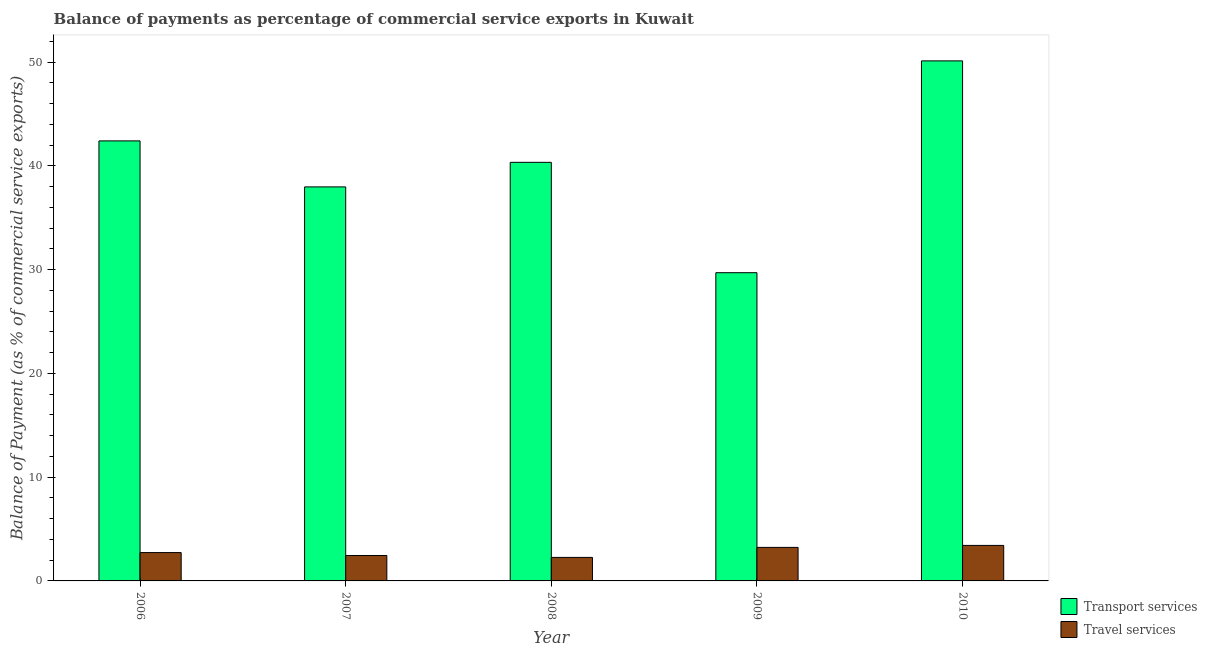How many different coloured bars are there?
Your answer should be compact. 2. Are the number of bars per tick equal to the number of legend labels?
Offer a terse response. Yes. Are the number of bars on each tick of the X-axis equal?
Your answer should be very brief. Yes. What is the label of the 2nd group of bars from the left?
Your answer should be compact. 2007. What is the balance of payments of transport services in 2009?
Offer a terse response. 29.71. Across all years, what is the maximum balance of payments of travel services?
Your response must be concise. 3.42. Across all years, what is the minimum balance of payments of travel services?
Your answer should be compact. 2.27. In which year was the balance of payments of transport services maximum?
Your answer should be compact. 2010. In which year was the balance of payments of transport services minimum?
Your answer should be very brief. 2009. What is the total balance of payments of transport services in the graph?
Give a very brief answer. 200.58. What is the difference between the balance of payments of transport services in 2006 and that in 2010?
Your answer should be very brief. -7.71. What is the difference between the balance of payments of travel services in 2010 and the balance of payments of transport services in 2007?
Ensure brevity in your answer.  0.97. What is the average balance of payments of transport services per year?
Your answer should be compact. 40.12. In how many years, is the balance of payments of transport services greater than 38 %?
Your response must be concise. 3. What is the ratio of the balance of payments of travel services in 2006 to that in 2007?
Offer a very short reply. 1.11. Is the difference between the balance of payments of travel services in 2006 and 2007 greater than the difference between the balance of payments of transport services in 2006 and 2007?
Your response must be concise. No. What is the difference between the highest and the second highest balance of payments of transport services?
Ensure brevity in your answer.  7.71. What is the difference between the highest and the lowest balance of payments of transport services?
Your response must be concise. 20.42. In how many years, is the balance of payments of transport services greater than the average balance of payments of transport services taken over all years?
Ensure brevity in your answer.  3. What does the 1st bar from the left in 2007 represents?
Give a very brief answer. Transport services. What does the 1st bar from the right in 2007 represents?
Give a very brief answer. Travel services. What is the difference between two consecutive major ticks on the Y-axis?
Offer a very short reply. 10. Are the values on the major ticks of Y-axis written in scientific E-notation?
Your answer should be very brief. No. Does the graph contain grids?
Give a very brief answer. No. How many legend labels are there?
Ensure brevity in your answer.  2. What is the title of the graph?
Make the answer very short. Balance of payments as percentage of commercial service exports in Kuwait. What is the label or title of the X-axis?
Offer a very short reply. Year. What is the label or title of the Y-axis?
Keep it short and to the point. Balance of Payment (as % of commercial service exports). What is the Balance of Payment (as % of commercial service exports) in Transport services in 2006?
Offer a very short reply. 42.41. What is the Balance of Payment (as % of commercial service exports) of Travel services in 2006?
Make the answer very short. 2.73. What is the Balance of Payment (as % of commercial service exports) in Transport services in 2007?
Give a very brief answer. 37.98. What is the Balance of Payment (as % of commercial service exports) of Travel services in 2007?
Your answer should be very brief. 2.45. What is the Balance of Payment (as % of commercial service exports) of Transport services in 2008?
Your answer should be very brief. 40.35. What is the Balance of Payment (as % of commercial service exports) of Travel services in 2008?
Your response must be concise. 2.27. What is the Balance of Payment (as % of commercial service exports) in Transport services in 2009?
Your answer should be very brief. 29.71. What is the Balance of Payment (as % of commercial service exports) in Travel services in 2009?
Keep it short and to the point. 3.23. What is the Balance of Payment (as % of commercial service exports) in Transport services in 2010?
Your answer should be compact. 50.13. What is the Balance of Payment (as % of commercial service exports) of Travel services in 2010?
Provide a succinct answer. 3.42. Across all years, what is the maximum Balance of Payment (as % of commercial service exports) of Transport services?
Keep it short and to the point. 50.13. Across all years, what is the maximum Balance of Payment (as % of commercial service exports) in Travel services?
Your answer should be very brief. 3.42. Across all years, what is the minimum Balance of Payment (as % of commercial service exports) in Transport services?
Your answer should be very brief. 29.71. Across all years, what is the minimum Balance of Payment (as % of commercial service exports) in Travel services?
Offer a terse response. 2.27. What is the total Balance of Payment (as % of commercial service exports) of Transport services in the graph?
Provide a succinct answer. 200.58. What is the total Balance of Payment (as % of commercial service exports) of Travel services in the graph?
Give a very brief answer. 14.1. What is the difference between the Balance of Payment (as % of commercial service exports) in Transport services in 2006 and that in 2007?
Give a very brief answer. 4.43. What is the difference between the Balance of Payment (as % of commercial service exports) of Travel services in 2006 and that in 2007?
Your answer should be very brief. 0.28. What is the difference between the Balance of Payment (as % of commercial service exports) of Transport services in 2006 and that in 2008?
Ensure brevity in your answer.  2.07. What is the difference between the Balance of Payment (as % of commercial service exports) of Travel services in 2006 and that in 2008?
Ensure brevity in your answer.  0.47. What is the difference between the Balance of Payment (as % of commercial service exports) of Transport services in 2006 and that in 2009?
Your answer should be compact. 12.7. What is the difference between the Balance of Payment (as % of commercial service exports) in Travel services in 2006 and that in 2009?
Provide a succinct answer. -0.5. What is the difference between the Balance of Payment (as % of commercial service exports) of Transport services in 2006 and that in 2010?
Provide a succinct answer. -7.71. What is the difference between the Balance of Payment (as % of commercial service exports) of Travel services in 2006 and that in 2010?
Your response must be concise. -0.69. What is the difference between the Balance of Payment (as % of commercial service exports) of Transport services in 2007 and that in 2008?
Keep it short and to the point. -2.37. What is the difference between the Balance of Payment (as % of commercial service exports) of Travel services in 2007 and that in 2008?
Ensure brevity in your answer.  0.18. What is the difference between the Balance of Payment (as % of commercial service exports) in Transport services in 2007 and that in 2009?
Your response must be concise. 8.27. What is the difference between the Balance of Payment (as % of commercial service exports) in Travel services in 2007 and that in 2009?
Offer a very short reply. -0.78. What is the difference between the Balance of Payment (as % of commercial service exports) in Transport services in 2007 and that in 2010?
Make the answer very short. -12.15. What is the difference between the Balance of Payment (as % of commercial service exports) of Travel services in 2007 and that in 2010?
Keep it short and to the point. -0.97. What is the difference between the Balance of Payment (as % of commercial service exports) of Transport services in 2008 and that in 2009?
Provide a short and direct response. 10.64. What is the difference between the Balance of Payment (as % of commercial service exports) of Travel services in 2008 and that in 2009?
Your answer should be very brief. -0.97. What is the difference between the Balance of Payment (as % of commercial service exports) of Transport services in 2008 and that in 2010?
Offer a very short reply. -9.78. What is the difference between the Balance of Payment (as % of commercial service exports) of Travel services in 2008 and that in 2010?
Make the answer very short. -1.16. What is the difference between the Balance of Payment (as % of commercial service exports) of Transport services in 2009 and that in 2010?
Your answer should be compact. -20.42. What is the difference between the Balance of Payment (as % of commercial service exports) in Travel services in 2009 and that in 2010?
Your answer should be very brief. -0.19. What is the difference between the Balance of Payment (as % of commercial service exports) in Transport services in 2006 and the Balance of Payment (as % of commercial service exports) in Travel services in 2007?
Your answer should be very brief. 39.96. What is the difference between the Balance of Payment (as % of commercial service exports) of Transport services in 2006 and the Balance of Payment (as % of commercial service exports) of Travel services in 2008?
Offer a terse response. 40.15. What is the difference between the Balance of Payment (as % of commercial service exports) of Transport services in 2006 and the Balance of Payment (as % of commercial service exports) of Travel services in 2009?
Provide a succinct answer. 39.18. What is the difference between the Balance of Payment (as % of commercial service exports) in Transport services in 2006 and the Balance of Payment (as % of commercial service exports) in Travel services in 2010?
Your answer should be very brief. 38.99. What is the difference between the Balance of Payment (as % of commercial service exports) of Transport services in 2007 and the Balance of Payment (as % of commercial service exports) of Travel services in 2008?
Ensure brevity in your answer.  35.72. What is the difference between the Balance of Payment (as % of commercial service exports) of Transport services in 2007 and the Balance of Payment (as % of commercial service exports) of Travel services in 2009?
Provide a succinct answer. 34.75. What is the difference between the Balance of Payment (as % of commercial service exports) in Transport services in 2007 and the Balance of Payment (as % of commercial service exports) in Travel services in 2010?
Keep it short and to the point. 34.56. What is the difference between the Balance of Payment (as % of commercial service exports) of Transport services in 2008 and the Balance of Payment (as % of commercial service exports) of Travel services in 2009?
Keep it short and to the point. 37.12. What is the difference between the Balance of Payment (as % of commercial service exports) of Transport services in 2008 and the Balance of Payment (as % of commercial service exports) of Travel services in 2010?
Keep it short and to the point. 36.92. What is the difference between the Balance of Payment (as % of commercial service exports) of Transport services in 2009 and the Balance of Payment (as % of commercial service exports) of Travel services in 2010?
Give a very brief answer. 26.29. What is the average Balance of Payment (as % of commercial service exports) in Transport services per year?
Give a very brief answer. 40.12. What is the average Balance of Payment (as % of commercial service exports) in Travel services per year?
Keep it short and to the point. 2.82. In the year 2006, what is the difference between the Balance of Payment (as % of commercial service exports) of Transport services and Balance of Payment (as % of commercial service exports) of Travel services?
Offer a very short reply. 39.68. In the year 2007, what is the difference between the Balance of Payment (as % of commercial service exports) in Transport services and Balance of Payment (as % of commercial service exports) in Travel services?
Make the answer very short. 35.53. In the year 2008, what is the difference between the Balance of Payment (as % of commercial service exports) in Transport services and Balance of Payment (as % of commercial service exports) in Travel services?
Offer a terse response. 38.08. In the year 2009, what is the difference between the Balance of Payment (as % of commercial service exports) of Transport services and Balance of Payment (as % of commercial service exports) of Travel services?
Your response must be concise. 26.48. In the year 2010, what is the difference between the Balance of Payment (as % of commercial service exports) in Transport services and Balance of Payment (as % of commercial service exports) in Travel services?
Make the answer very short. 46.7. What is the ratio of the Balance of Payment (as % of commercial service exports) in Transport services in 2006 to that in 2007?
Your answer should be compact. 1.12. What is the ratio of the Balance of Payment (as % of commercial service exports) of Travel services in 2006 to that in 2007?
Your answer should be very brief. 1.11. What is the ratio of the Balance of Payment (as % of commercial service exports) in Transport services in 2006 to that in 2008?
Your answer should be compact. 1.05. What is the ratio of the Balance of Payment (as % of commercial service exports) of Travel services in 2006 to that in 2008?
Your response must be concise. 1.21. What is the ratio of the Balance of Payment (as % of commercial service exports) in Transport services in 2006 to that in 2009?
Your response must be concise. 1.43. What is the ratio of the Balance of Payment (as % of commercial service exports) of Travel services in 2006 to that in 2009?
Provide a short and direct response. 0.85. What is the ratio of the Balance of Payment (as % of commercial service exports) of Transport services in 2006 to that in 2010?
Offer a very short reply. 0.85. What is the ratio of the Balance of Payment (as % of commercial service exports) in Travel services in 2006 to that in 2010?
Ensure brevity in your answer.  0.8. What is the ratio of the Balance of Payment (as % of commercial service exports) in Transport services in 2007 to that in 2008?
Make the answer very short. 0.94. What is the ratio of the Balance of Payment (as % of commercial service exports) of Travel services in 2007 to that in 2008?
Ensure brevity in your answer.  1.08. What is the ratio of the Balance of Payment (as % of commercial service exports) of Transport services in 2007 to that in 2009?
Make the answer very short. 1.28. What is the ratio of the Balance of Payment (as % of commercial service exports) of Travel services in 2007 to that in 2009?
Your response must be concise. 0.76. What is the ratio of the Balance of Payment (as % of commercial service exports) in Transport services in 2007 to that in 2010?
Give a very brief answer. 0.76. What is the ratio of the Balance of Payment (as % of commercial service exports) of Travel services in 2007 to that in 2010?
Your response must be concise. 0.72. What is the ratio of the Balance of Payment (as % of commercial service exports) in Transport services in 2008 to that in 2009?
Offer a very short reply. 1.36. What is the ratio of the Balance of Payment (as % of commercial service exports) in Travel services in 2008 to that in 2009?
Offer a very short reply. 0.7. What is the ratio of the Balance of Payment (as % of commercial service exports) of Transport services in 2008 to that in 2010?
Keep it short and to the point. 0.8. What is the ratio of the Balance of Payment (as % of commercial service exports) in Travel services in 2008 to that in 2010?
Offer a very short reply. 0.66. What is the ratio of the Balance of Payment (as % of commercial service exports) in Transport services in 2009 to that in 2010?
Your answer should be very brief. 0.59. What is the ratio of the Balance of Payment (as % of commercial service exports) in Travel services in 2009 to that in 2010?
Your response must be concise. 0.94. What is the difference between the highest and the second highest Balance of Payment (as % of commercial service exports) of Transport services?
Your answer should be compact. 7.71. What is the difference between the highest and the second highest Balance of Payment (as % of commercial service exports) of Travel services?
Provide a succinct answer. 0.19. What is the difference between the highest and the lowest Balance of Payment (as % of commercial service exports) in Transport services?
Offer a terse response. 20.42. What is the difference between the highest and the lowest Balance of Payment (as % of commercial service exports) of Travel services?
Provide a succinct answer. 1.16. 